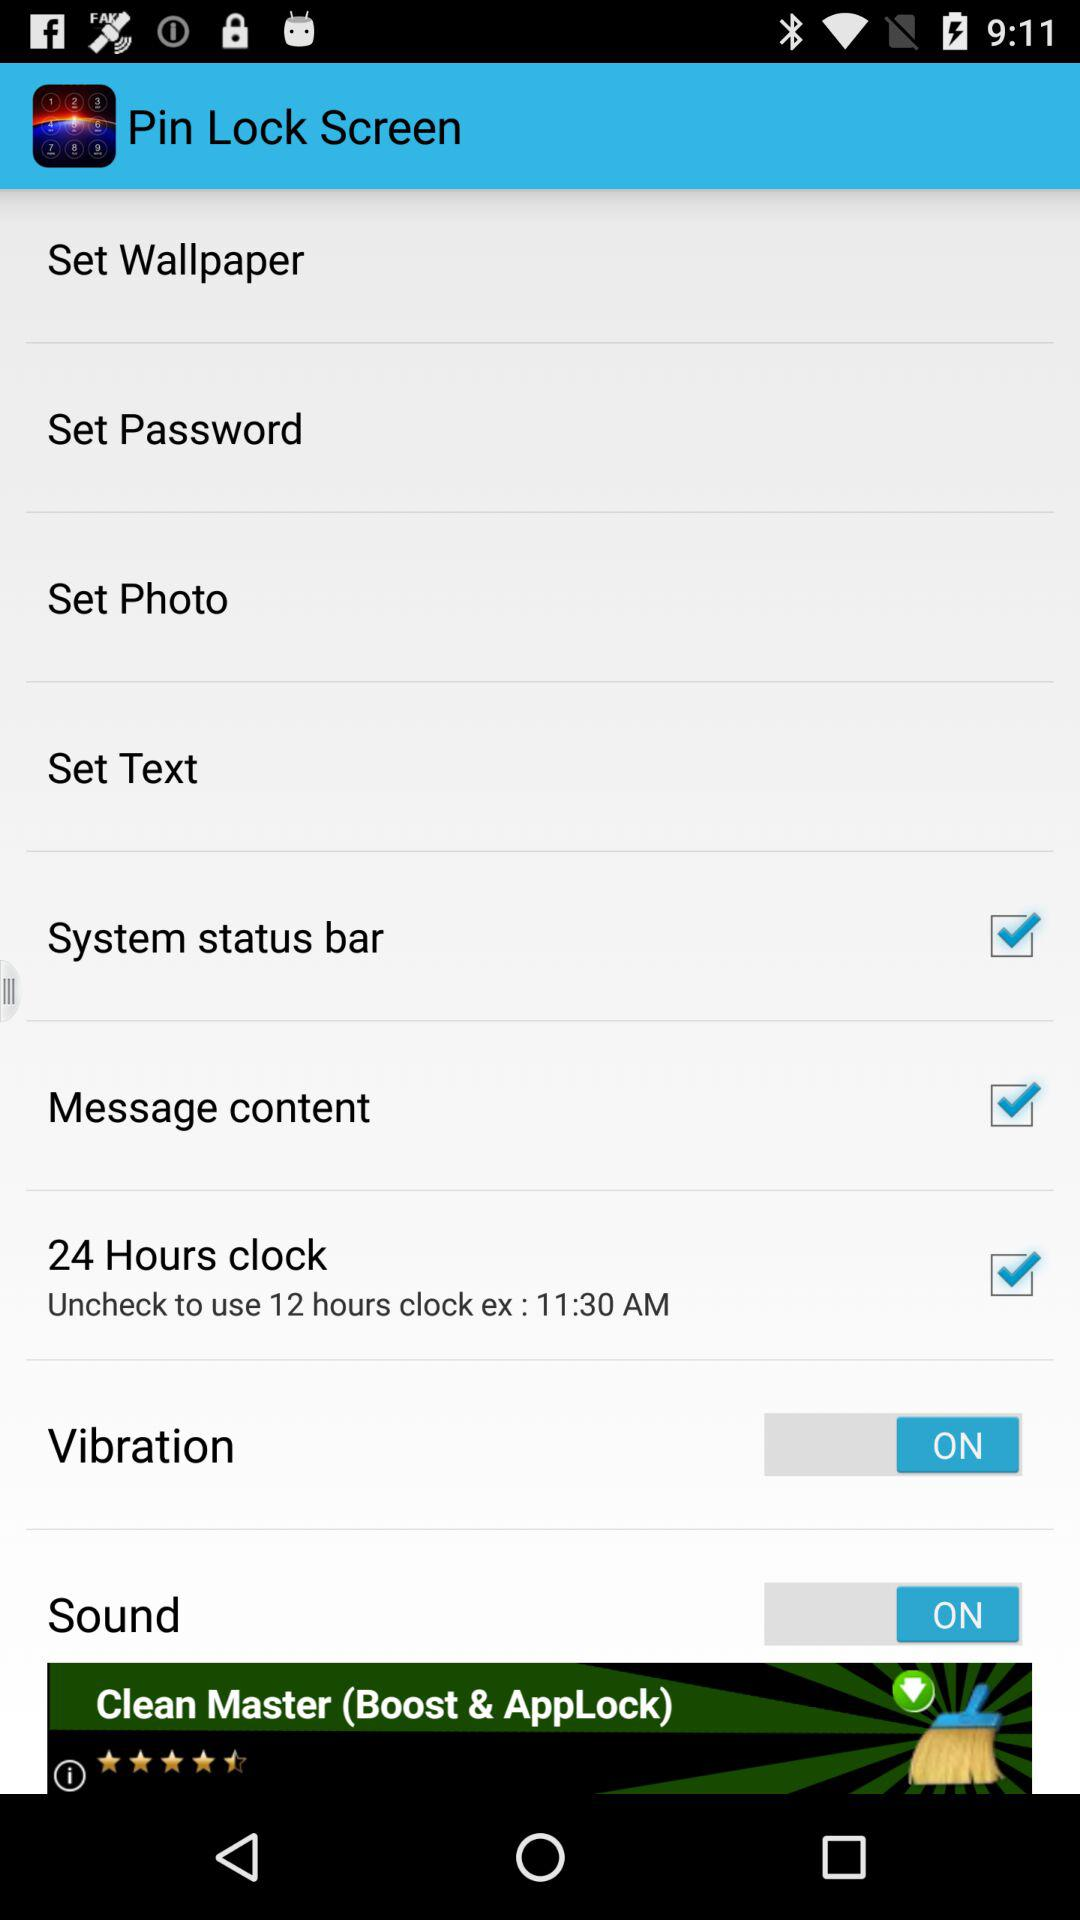Which type of clock format is used? The type of clock format used is a 24-hour clock. 